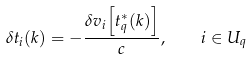Convert formula to latex. <formula><loc_0><loc_0><loc_500><loc_500>\delta t _ { i } ( k ) = - \frac { \delta v _ { i } { \left [ { t _ { q } ^ { \ast } ( k ) } \right ] } } { c } , \quad i \in U _ { q }</formula> 